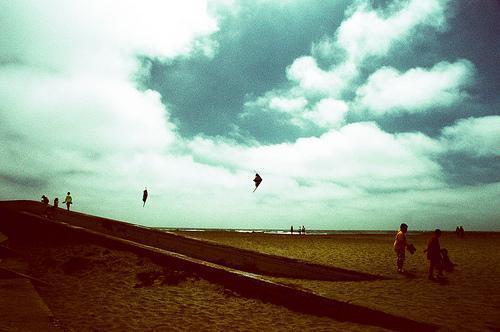How many kites are in the sky?
Give a very brief answer. 2. How many walls are visible in the picture?
Give a very brief answer. 2. 